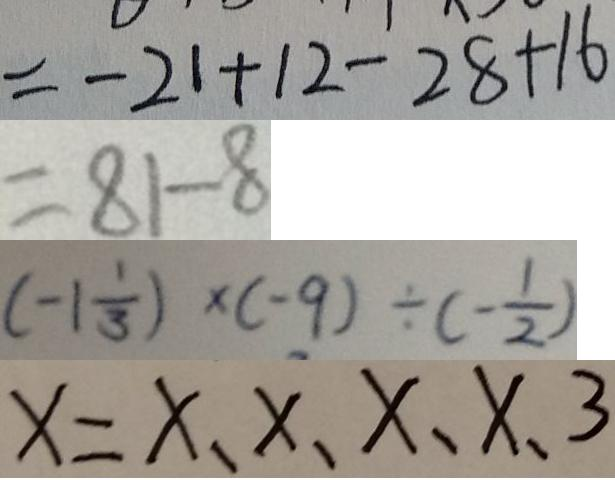Convert formula to latex. <formula><loc_0><loc_0><loc_500><loc_500>= - 2 1 + 1 2 - 2 8 + 1 6 
 = 8 1 - 8 
 ( - 1 \frac { 1 } { 3 } ) \times ( - 9 ) \div ( - \frac { 1 } { 2 } ) 
 x = x 、 x 、 x 、 x 、 3</formula> 